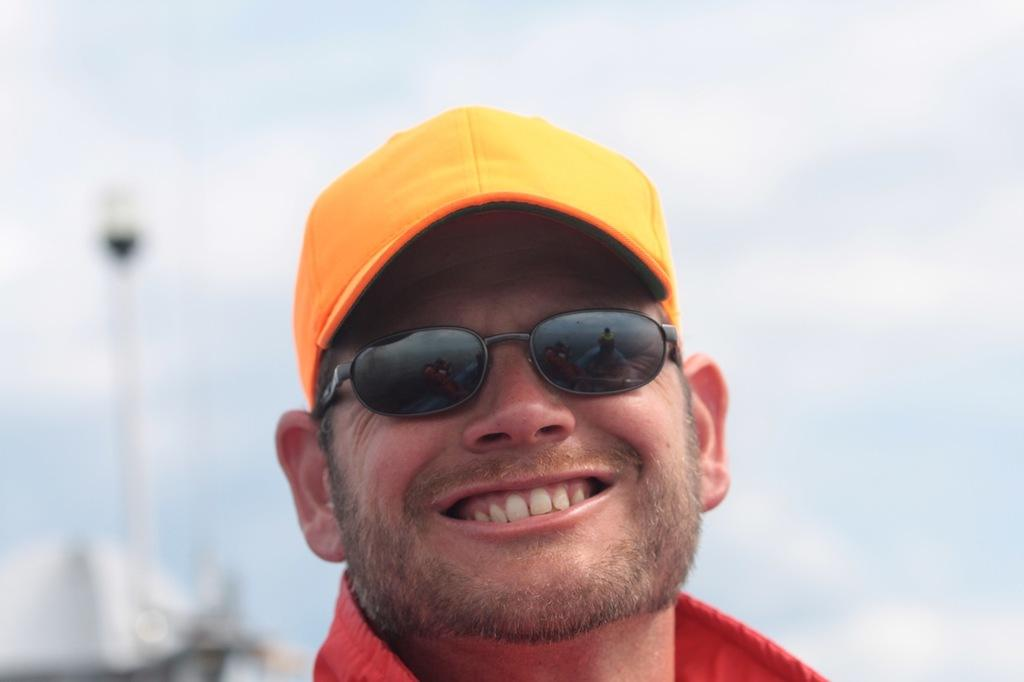What can be observed about the person in the image? There is a person in the image, and they are smiling. What accessories is the person wearing? The person is wearing spectacles and a cap. Can you describe the background of the image? The background of the image is blurred. Did the person experience any pleasure from an earthquake in the image? There is no mention of an earthquake or any pleasure experienced by the person in the image. 